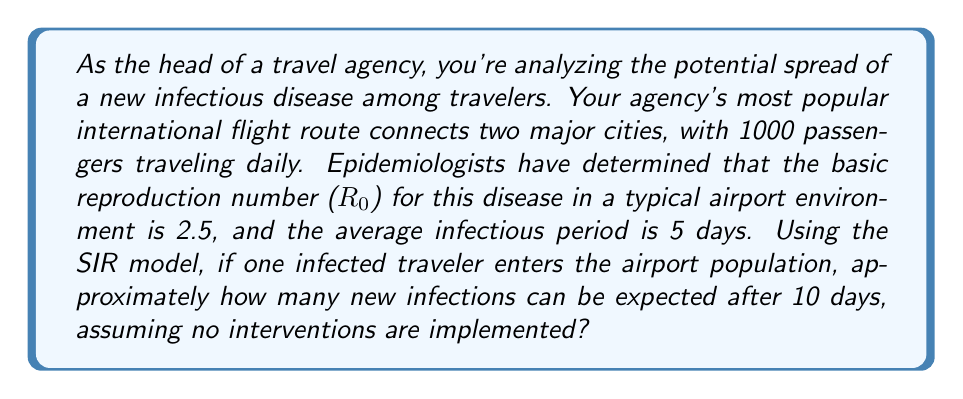Show me your answer to this math problem. To solve this problem, we'll use the SIR (Susceptible-Infectious-Recovered) model, which is commonly used in epidemiology. The basic reproduction number ($R_0$) and the infectious period are key parameters in this model.

1) First, we need to calculate the transmission rate ($\beta$) using the given information:
   $R_0 = \beta \times N \times D$
   Where:
   $R_0 = 2.5$ (given)
   $N = 1000$ (daily passenger count, assuming this represents the average population in the airport)
   $D = 5$ days (average infectious period)

   $2.5 = \beta \times 1000 \times 5$
   $\beta = \frac{2.5}{5000} = 0.0005$

2) Next, we need to calculate the recovery rate ($\gamma$):
   $\gamma = \frac{1}{D} = \frac{1}{5} = 0.2$

3) Now we can use the SIR model differential equations:
   $$\frac{dS}{dt} = -\beta SI$$
   $$\frac{dI}{dt} = \beta SI - \gamma I$$
   $$\frac{dR}{dt} = \gamma I$$

4) To estimate the number of new infections after 10 days, we can use a simplified exponential growth model:
   $I(t) = I_0 e^{rt}$
   Where:
   $I_0 = 1$ (initial infected)
   $r = \beta S - \gamma$ (net growth rate)
   $t = 10$ days

5) Calculate $r$:
   $r = (0.0005 \times 999) - 0.2 = 0.2995$

6) Now we can calculate $I(10)$:
   $I(10) = 1 \times e^{0.2995 \times 10} \approx 20.02$

7) The number of new infections is the total infections minus the initial infected:
   New infections $\approx 20.02 - 1 = 19.02$
Answer: Approximately 19 new infections can be expected after 10 days. 